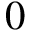Convert formula to latex. <formula><loc_0><loc_0><loc_500><loc_500>0</formula> 